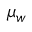Convert formula to latex. <formula><loc_0><loc_0><loc_500><loc_500>{ \mu } _ { w }</formula> 